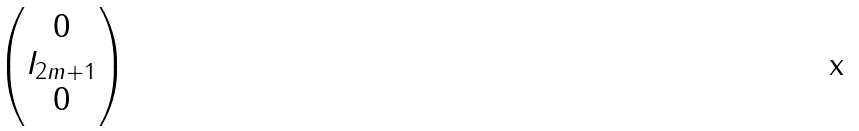<formula> <loc_0><loc_0><loc_500><loc_500>\begin{pmatrix} 0 \\ I _ { 2 m + 1 } \\ 0 \end{pmatrix}</formula> 